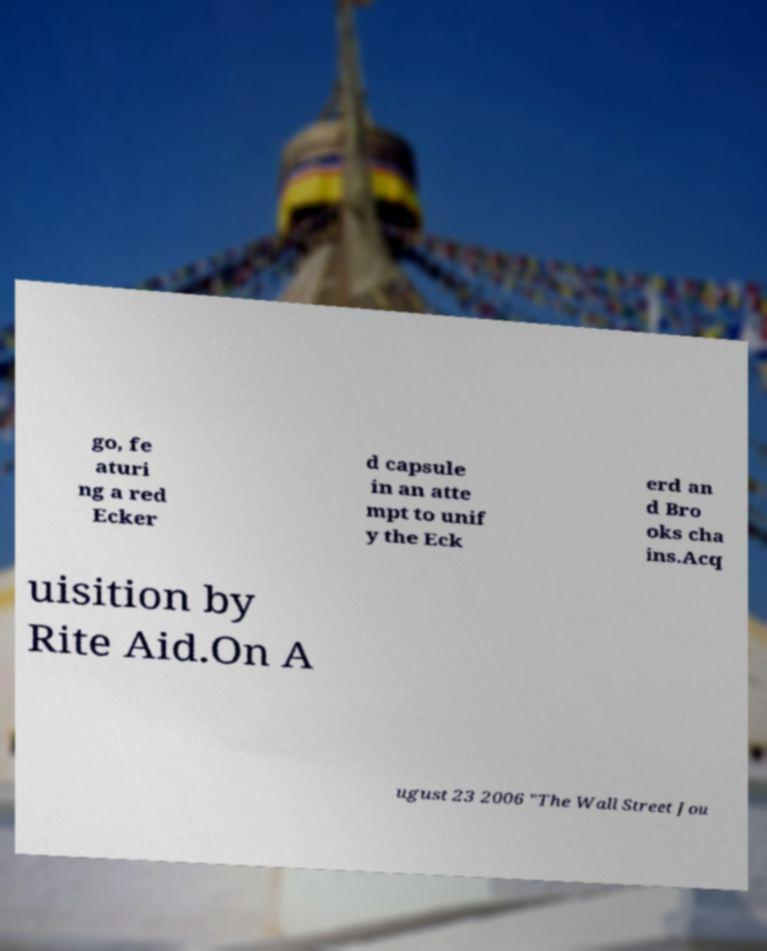There's text embedded in this image that I need extracted. Can you transcribe it verbatim? go, fe aturi ng a red Ecker d capsule in an atte mpt to unif y the Eck erd an d Bro oks cha ins.Acq uisition by Rite Aid.On A ugust 23 2006 "The Wall Street Jou 